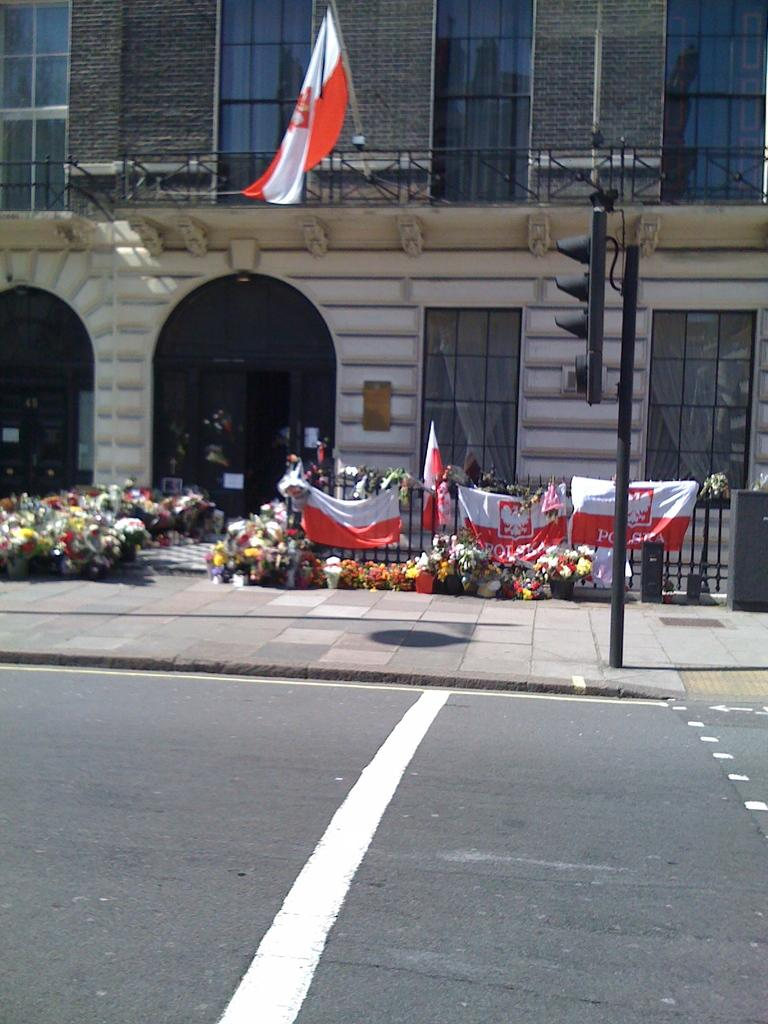What type of structure is visible in the image? There is a building with windows in the image. What is located near the building? There is a fence in the image. What can be seen flying in the image? There are flags in the image. What is growing in pots in the image? There is a group of plants with flowers in pots in the image. What controls traffic in the image? There is a traffic signal in the image. What surface can vehicles be seen on in the image? There is a road in the image. Where is the crown placed in the image? There is no crown present in the image. What type of writing instrument is being used by the plants in the image? The plants in the image are not using any writing instruments, as they are not capable of such actions. 